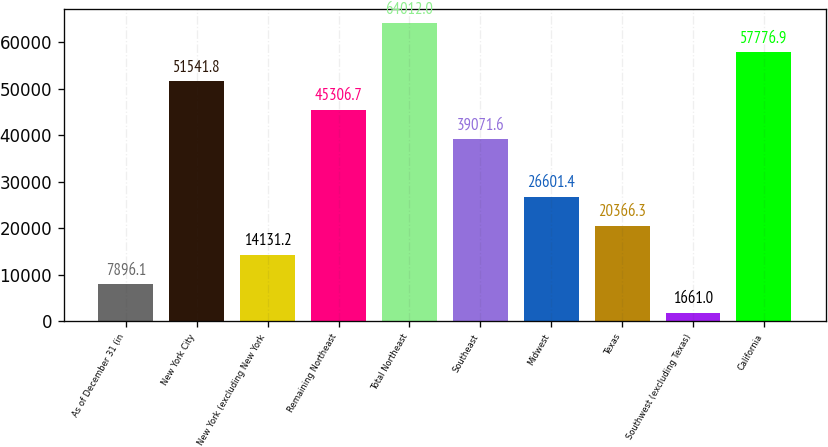Convert chart. <chart><loc_0><loc_0><loc_500><loc_500><bar_chart><fcel>As of December 31 (in<fcel>New York City<fcel>New York (excluding New York<fcel>Remaining Northeast<fcel>Total Northeast<fcel>Southeast<fcel>Midwest<fcel>Texas<fcel>Southwest (excluding Texas)<fcel>California<nl><fcel>7896.1<fcel>51541.8<fcel>14131.2<fcel>45306.7<fcel>64012<fcel>39071.6<fcel>26601.4<fcel>20366.3<fcel>1661<fcel>57776.9<nl></chart> 